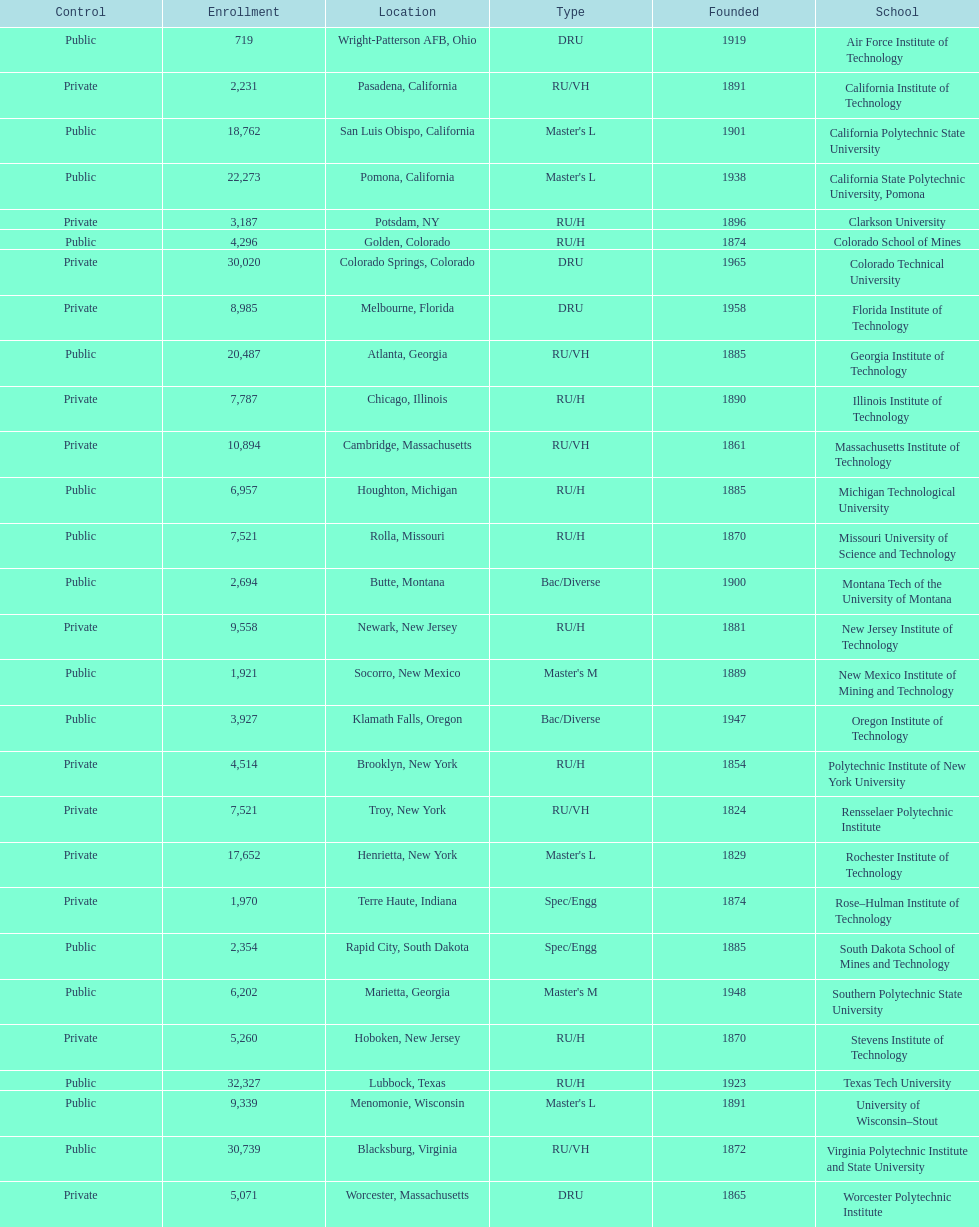How many of the universities were located in california? 3. 